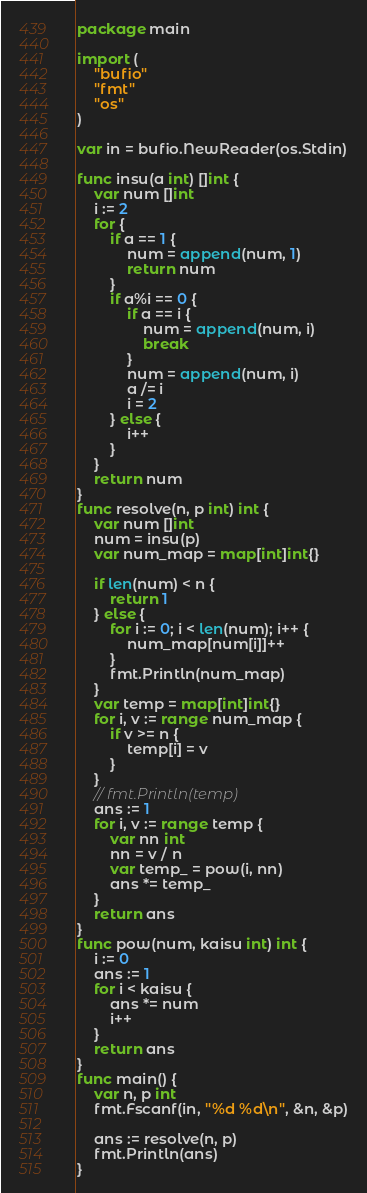<code> <loc_0><loc_0><loc_500><loc_500><_Go_>package main

import (
	"bufio"
	"fmt"
	"os"
)

var in = bufio.NewReader(os.Stdin)

func insu(a int) []int {
	var num []int
	i := 2
	for {
		if a == 1 {
			num = append(num, 1)
			return num
		}
		if a%i == 0 {
			if a == i {
				num = append(num, i)
				break
			}
			num = append(num, i)
			a /= i
			i = 2
		} else {
			i++
		}
	}
	return num
}
func resolve(n, p int) int {
	var num []int
	num = insu(p)
	var num_map = map[int]int{}

	if len(num) < n {
		return 1
	} else {
		for i := 0; i < len(num); i++ {
			num_map[num[i]]++
		}
		fmt.Println(num_map)
	}
	var temp = map[int]int{}
	for i, v := range num_map {
		if v >= n {
			temp[i] = v
		}
	}
	// fmt.Println(temp)
	ans := 1
	for i, v := range temp {
		var nn int
		nn = v / n
		var temp_ = pow(i, nn)
		ans *= temp_
	}
	return ans
}
func pow(num, kaisu int) int {
	i := 0
	ans := 1
	for i < kaisu {
		ans *= num
		i++
	}
	return ans
}
func main() {
	var n, p int
	fmt.Fscanf(in, "%d %d\n", &n, &p)

	ans := resolve(n, p)
	fmt.Println(ans)
}
</code> 